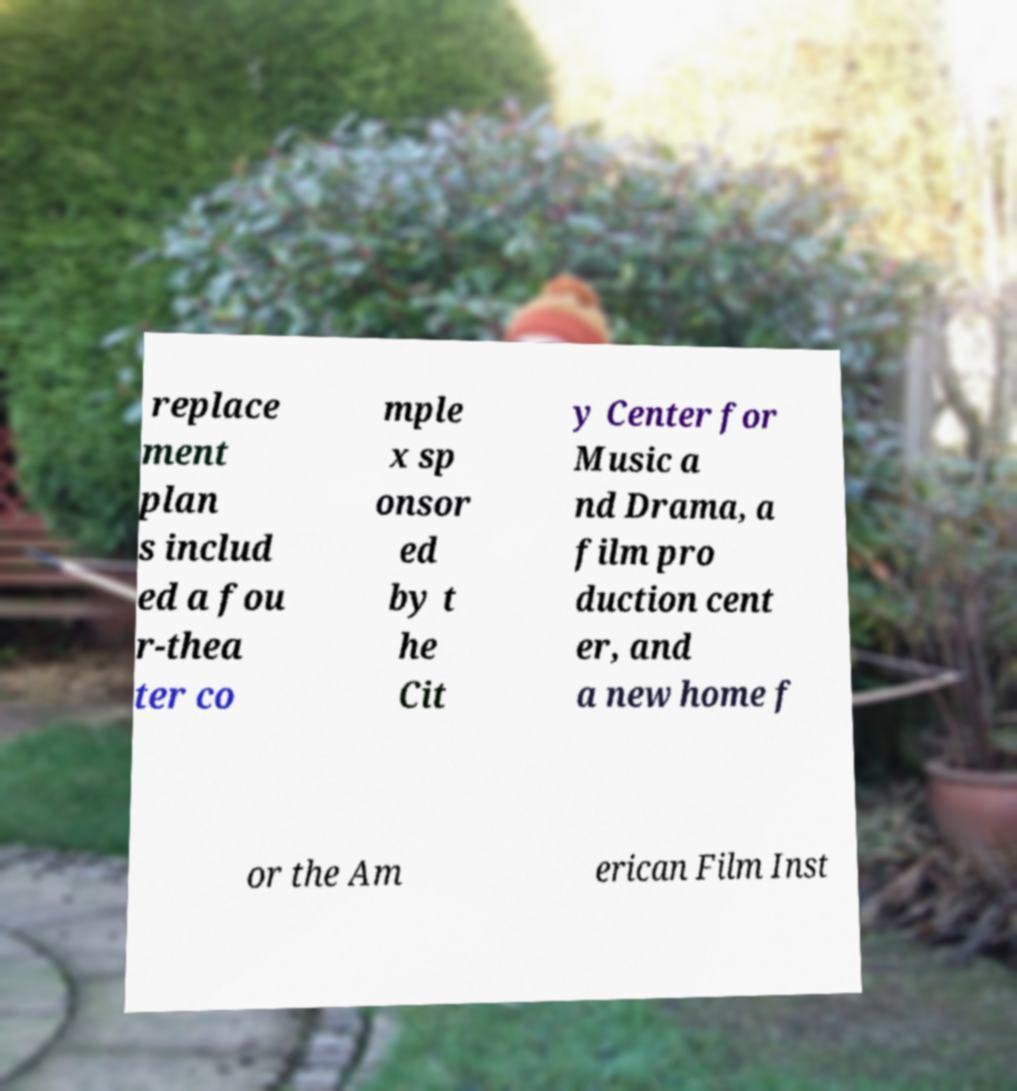I need the written content from this picture converted into text. Can you do that? replace ment plan s includ ed a fou r-thea ter co mple x sp onsor ed by t he Cit y Center for Music a nd Drama, a film pro duction cent er, and a new home f or the Am erican Film Inst 